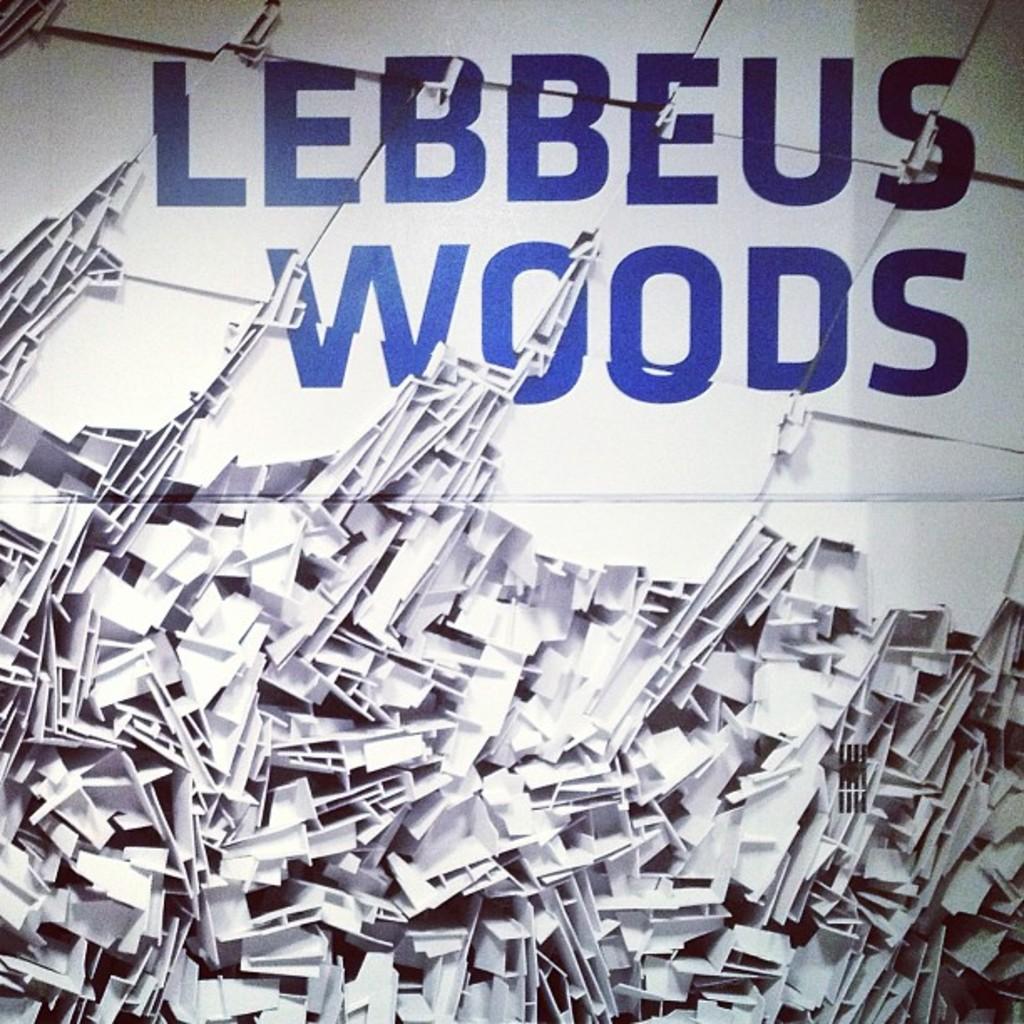Whats the woods about?
Offer a very short reply. Unanswerable. 